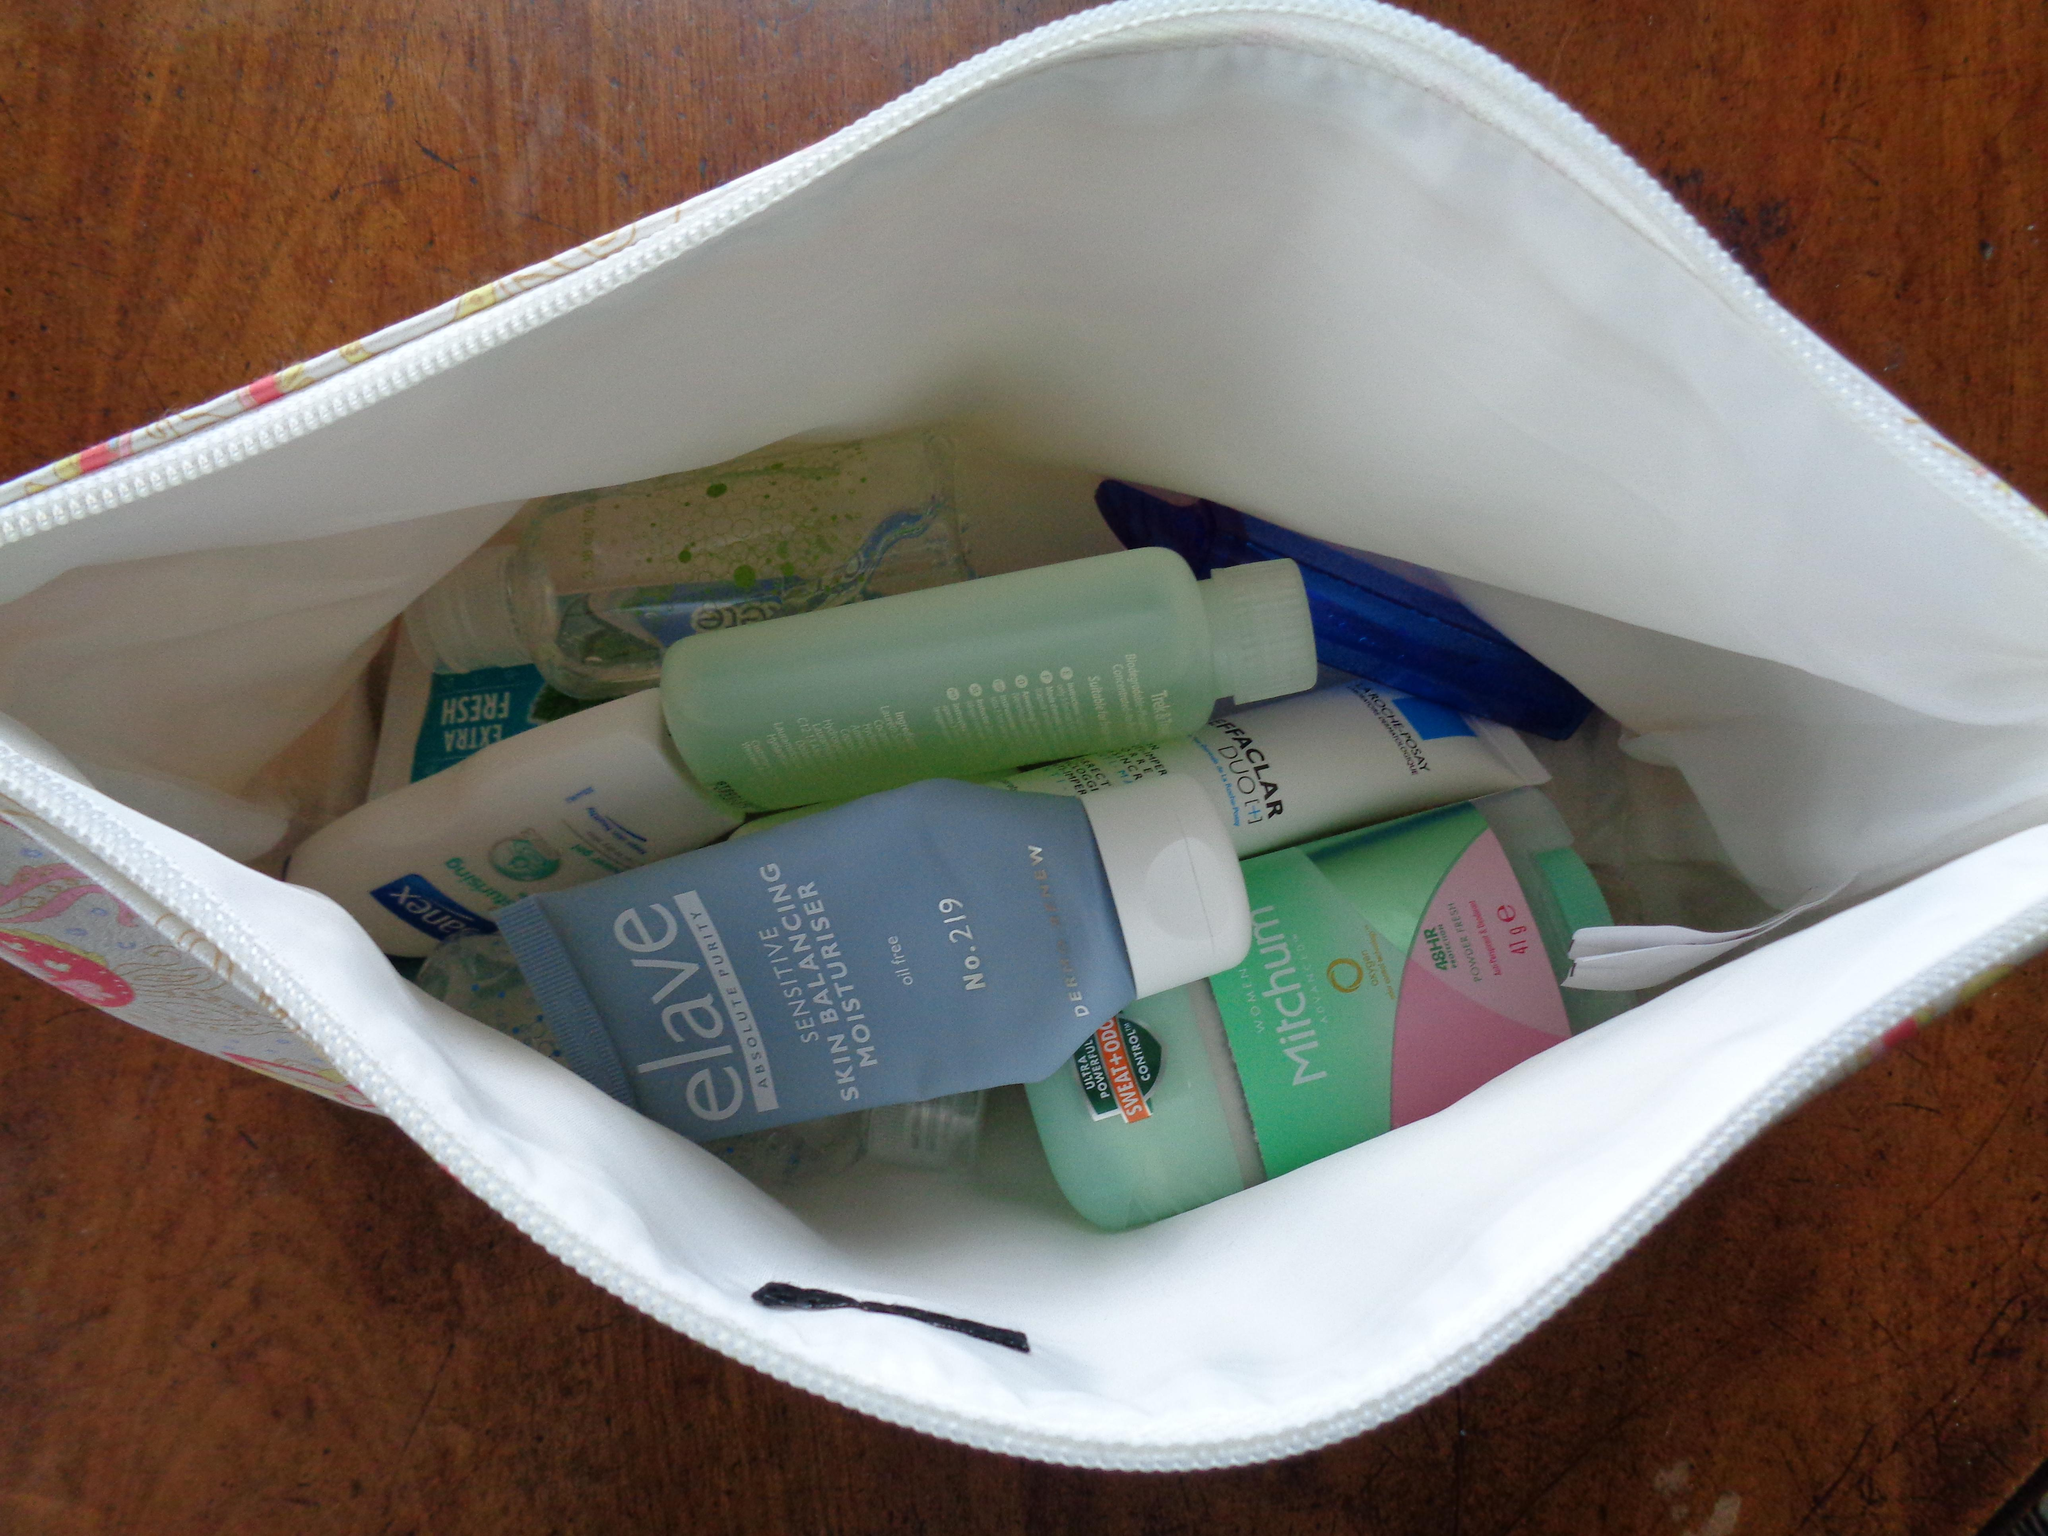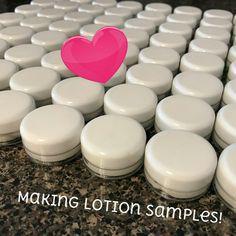The first image is the image on the left, the second image is the image on the right. Analyze the images presented: Is the assertion "Left and right images show similarly-shaped clear glass open-topped jars containing a creamy substance." valid? Answer yes or no. No. The first image is the image on the left, the second image is the image on the right. For the images shown, is this caption "There are two glass jars and they are both open." true? Answer yes or no. No. 